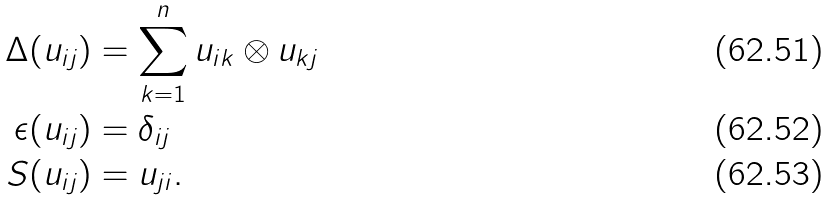<formula> <loc_0><loc_0><loc_500><loc_500>\Delta ( u _ { i j } ) & = \sum _ { k = 1 } ^ { n } u _ { i k } \otimes u _ { k j } \\ \epsilon ( u _ { i j } ) & = \delta _ { i j } \\ S ( u _ { i j } ) & = u _ { j i } .</formula> 